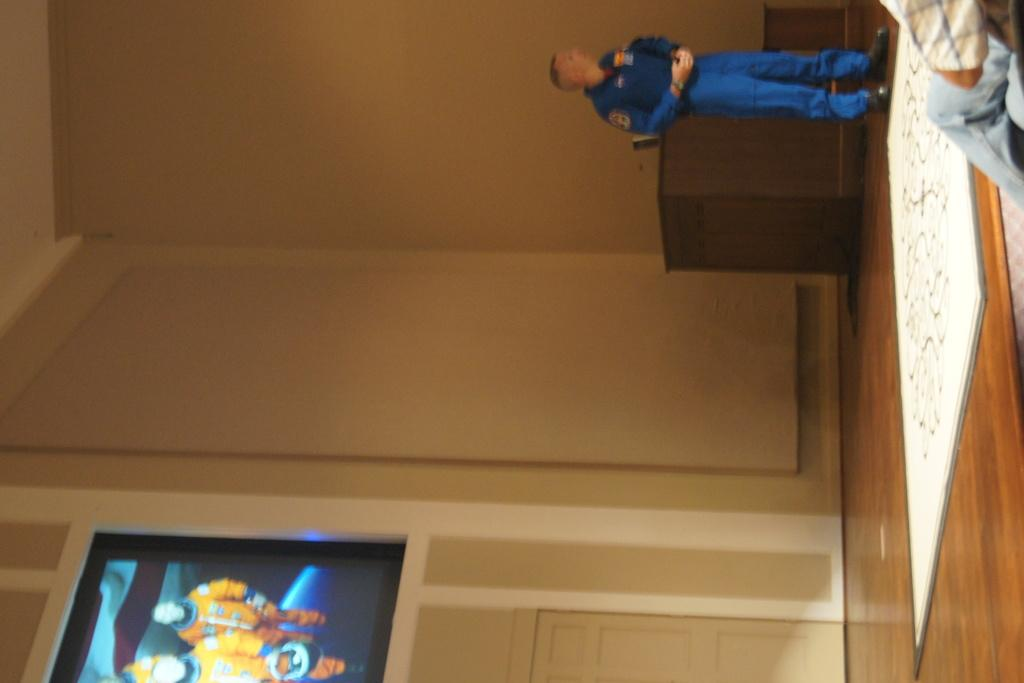What is the orientation of the image? The image is horizontal. What object can be seen in the image? There is a table in the image. What is the person in the image doing? A person is standing in front of the table. What is the photo frame attached to in the image? There is a photo frame on a pole in the image. How much payment is required for the trip shown in the image? There is no trip or payment mentioned in the image; it only shows a table, a person, and a photo frame on a pole. 